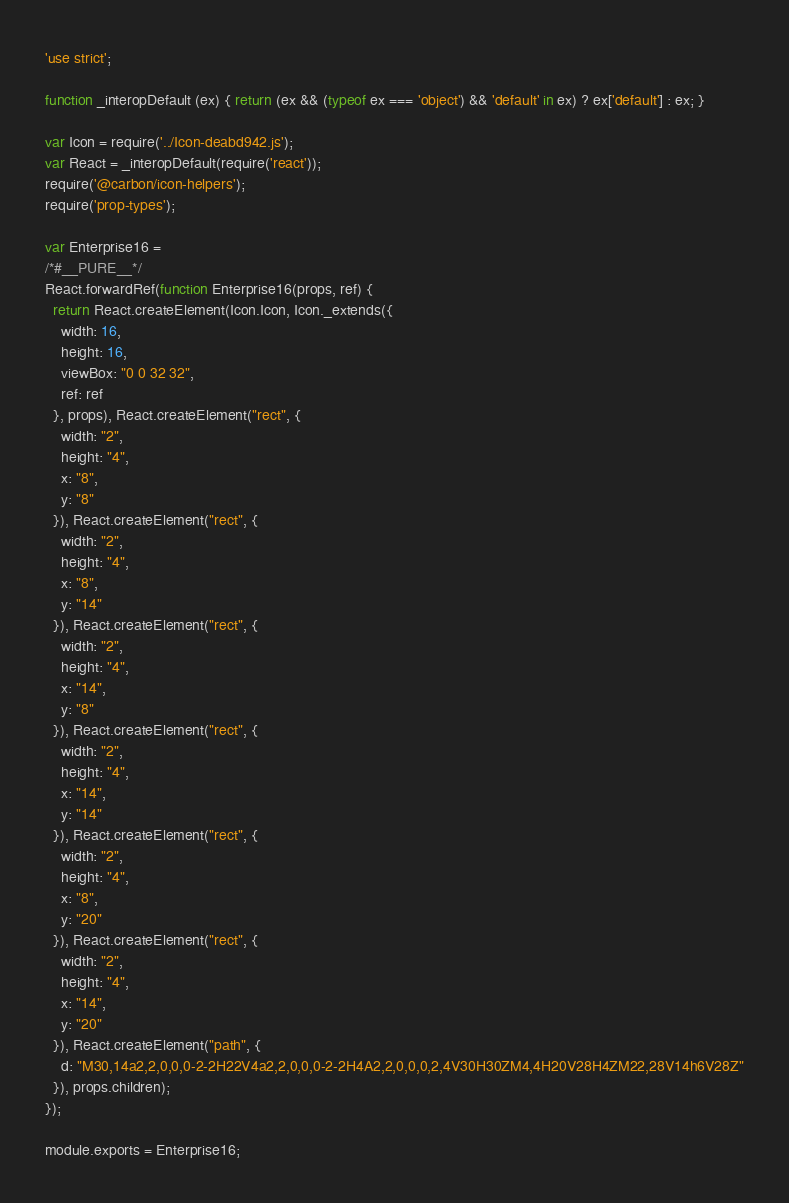Convert code to text. <code><loc_0><loc_0><loc_500><loc_500><_JavaScript_>'use strict';

function _interopDefault (ex) { return (ex && (typeof ex === 'object') && 'default' in ex) ? ex['default'] : ex; }

var Icon = require('../Icon-deabd942.js');
var React = _interopDefault(require('react'));
require('@carbon/icon-helpers');
require('prop-types');

var Enterprise16 =
/*#__PURE__*/
React.forwardRef(function Enterprise16(props, ref) {
  return React.createElement(Icon.Icon, Icon._extends({
    width: 16,
    height: 16,
    viewBox: "0 0 32 32",
    ref: ref
  }, props), React.createElement("rect", {
    width: "2",
    height: "4",
    x: "8",
    y: "8"
  }), React.createElement("rect", {
    width: "2",
    height: "4",
    x: "8",
    y: "14"
  }), React.createElement("rect", {
    width: "2",
    height: "4",
    x: "14",
    y: "8"
  }), React.createElement("rect", {
    width: "2",
    height: "4",
    x: "14",
    y: "14"
  }), React.createElement("rect", {
    width: "2",
    height: "4",
    x: "8",
    y: "20"
  }), React.createElement("rect", {
    width: "2",
    height: "4",
    x: "14",
    y: "20"
  }), React.createElement("path", {
    d: "M30,14a2,2,0,0,0-2-2H22V4a2,2,0,0,0-2-2H4A2,2,0,0,0,2,4V30H30ZM4,4H20V28H4ZM22,28V14h6V28Z"
  }), props.children);
});

module.exports = Enterprise16;
</code> 